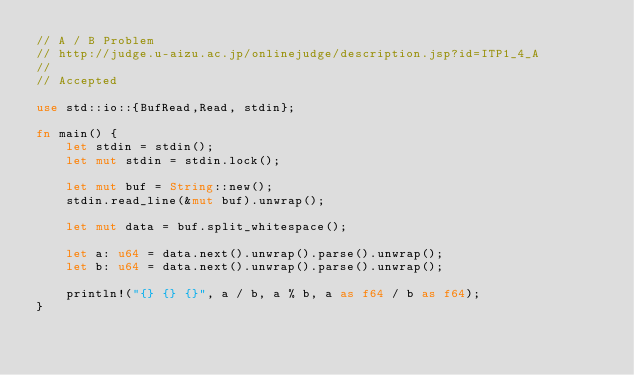<code> <loc_0><loc_0><loc_500><loc_500><_Rust_>// A / B Problem
// http://judge.u-aizu.ac.jp/onlinejudge/description.jsp?id=ITP1_4_A
//
// Accepted

use std::io::{BufRead,Read, stdin};

fn main() {
    let stdin = stdin();
    let mut stdin = stdin.lock();

    let mut buf = String::new();
    stdin.read_line(&mut buf).unwrap();

    let mut data = buf.split_whitespace();

    let a: u64 = data.next().unwrap().parse().unwrap();
    let b: u64 = data.next().unwrap().parse().unwrap();

    println!("{} {} {}", a / b, a % b, a as f64 / b as f64);
}
</code> 